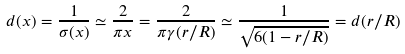<formula> <loc_0><loc_0><loc_500><loc_500>d ( x ) = \frac { 1 } { \sigma ( x ) } \simeq \frac { 2 } { \pi x } = \frac { 2 } { \pi \gamma ( r / R ) } \simeq \frac { 1 } { \sqrt { 6 ( 1 - r / R ) } } = d ( r / R )</formula> 